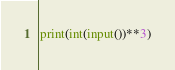Convert code to text. <code><loc_0><loc_0><loc_500><loc_500><_Python_>print(int(input())**3)</code> 